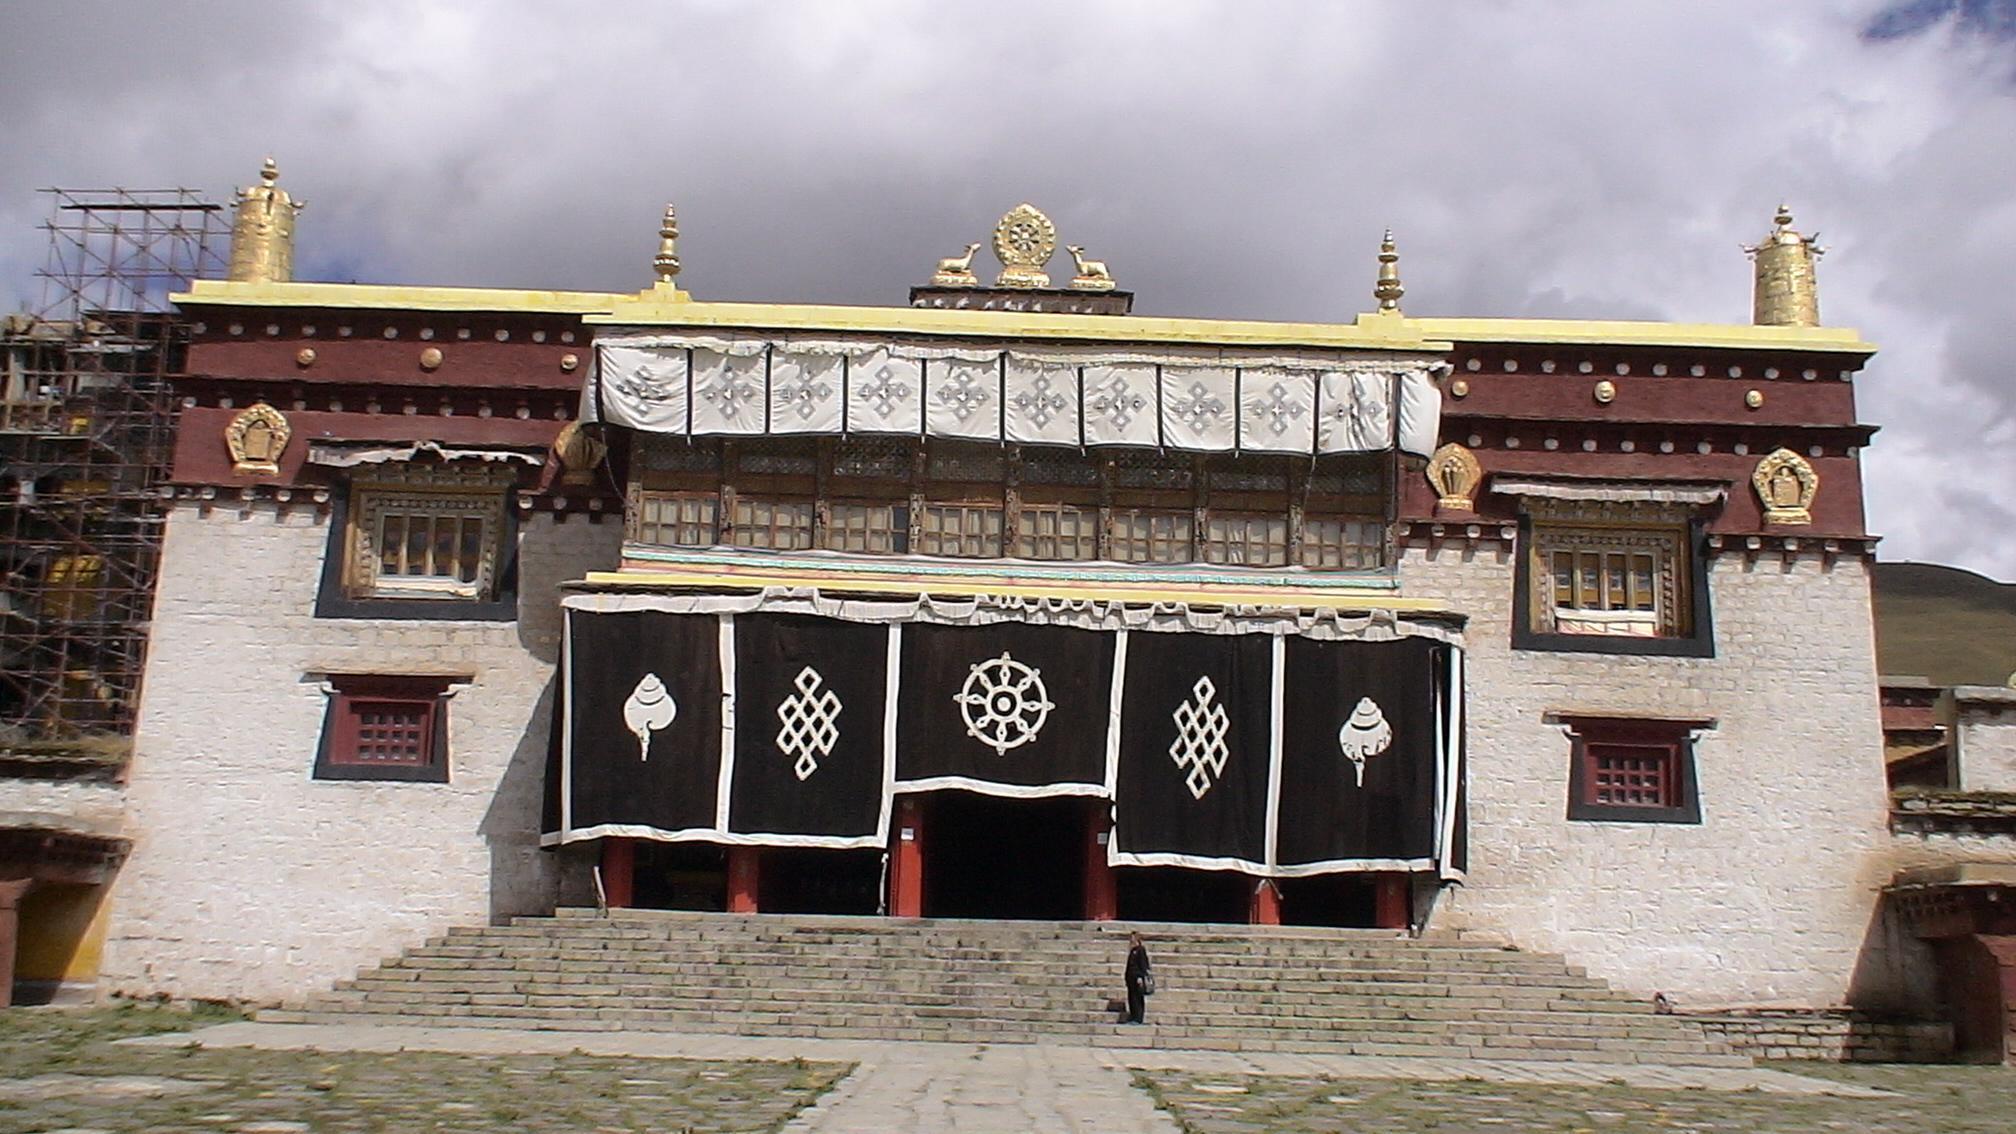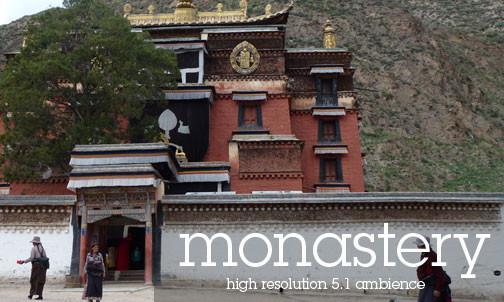The first image is the image on the left, the second image is the image on the right. For the images displayed, is the sentence "A jagged, staircase-like wall goes up a hillside with a monastery on top, in one image." factually correct? Answer yes or no. No. The first image is the image on the left, the second image is the image on the right. For the images displayed, is the sentence "In one image, the walls running up the mountain towards a monastery are built up the steep slopes in a stair-like design." factually correct? Answer yes or no. No. 